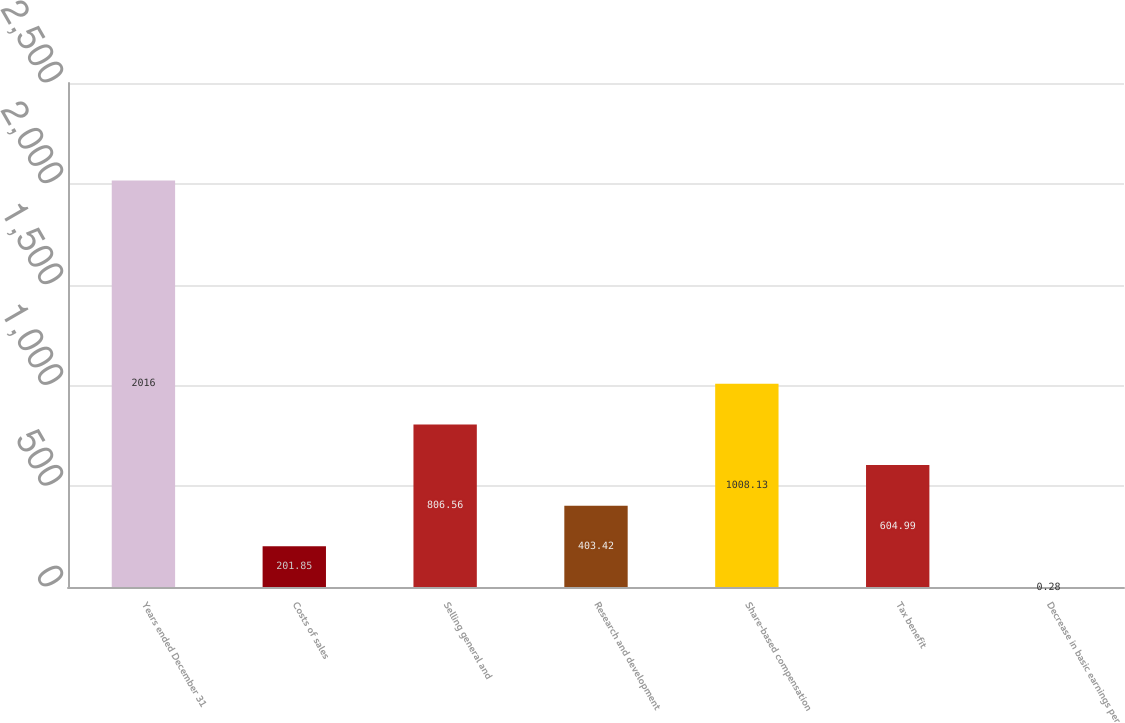Convert chart. <chart><loc_0><loc_0><loc_500><loc_500><bar_chart><fcel>Years ended December 31<fcel>Costs of sales<fcel>Selling general and<fcel>Research and development<fcel>Share-based compensation<fcel>Tax benefit<fcel>Decrease in basic earnings per<nl><fcel>2016<fcel>201.85<fcel>806.56<fcel>403.42<fcel>1008.13<fcel>604.99<fcel>0.28<nl></chart> 